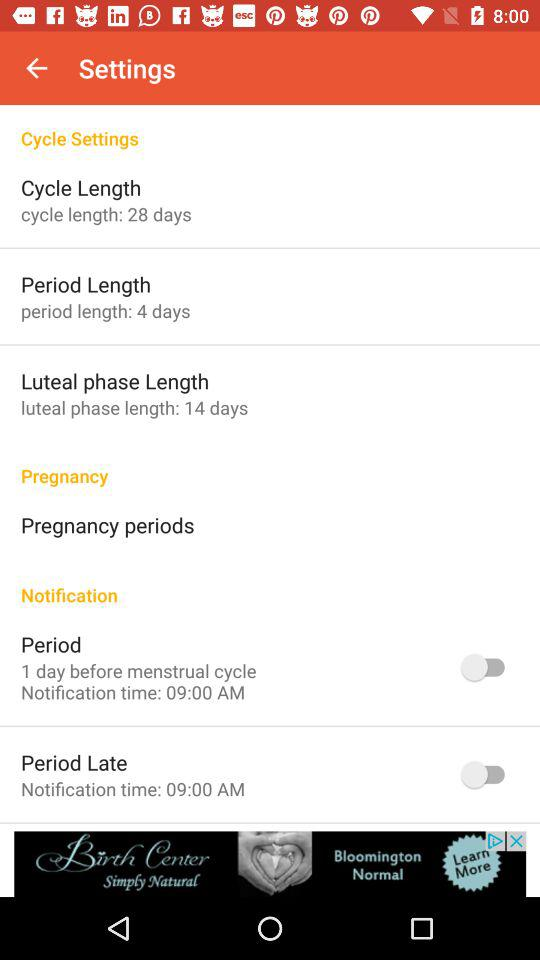How many days is the luteal phase of the cycle?
Answer the question using a single word or phrase. 14 days 